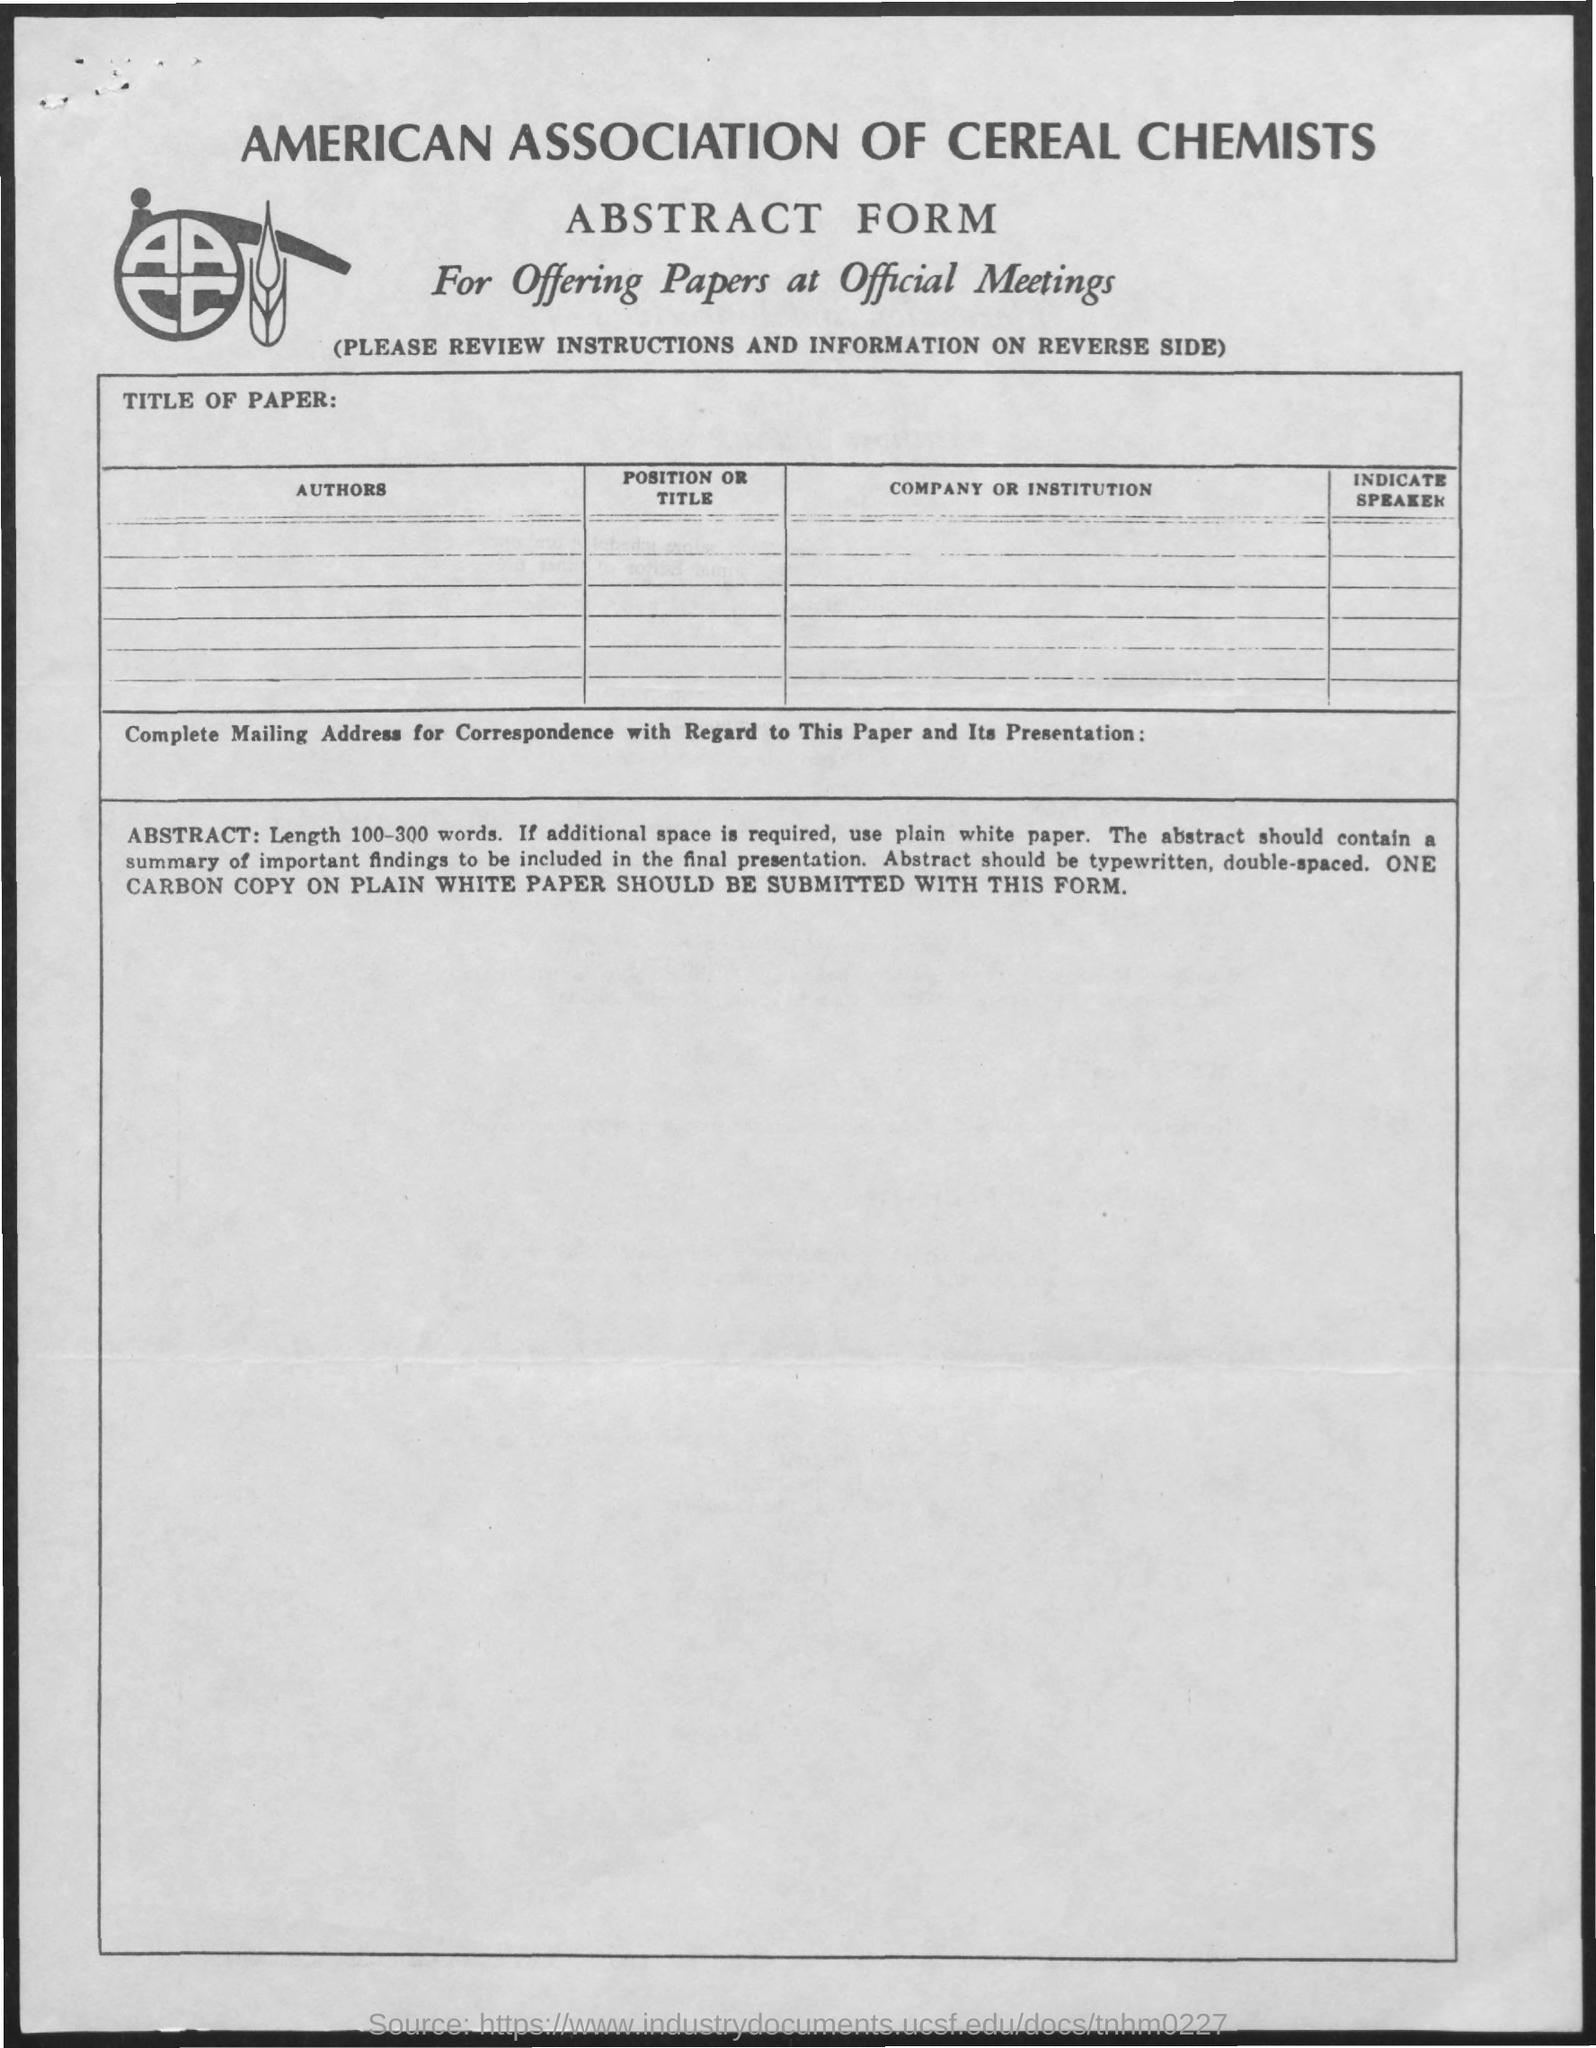What is the name of the association mentioned in the given form ?
Provide a succinct answer. American association of cereal chemists. What is the name of the form mentioned in the given page ?
Provide a short and direct response. Abstract form. 